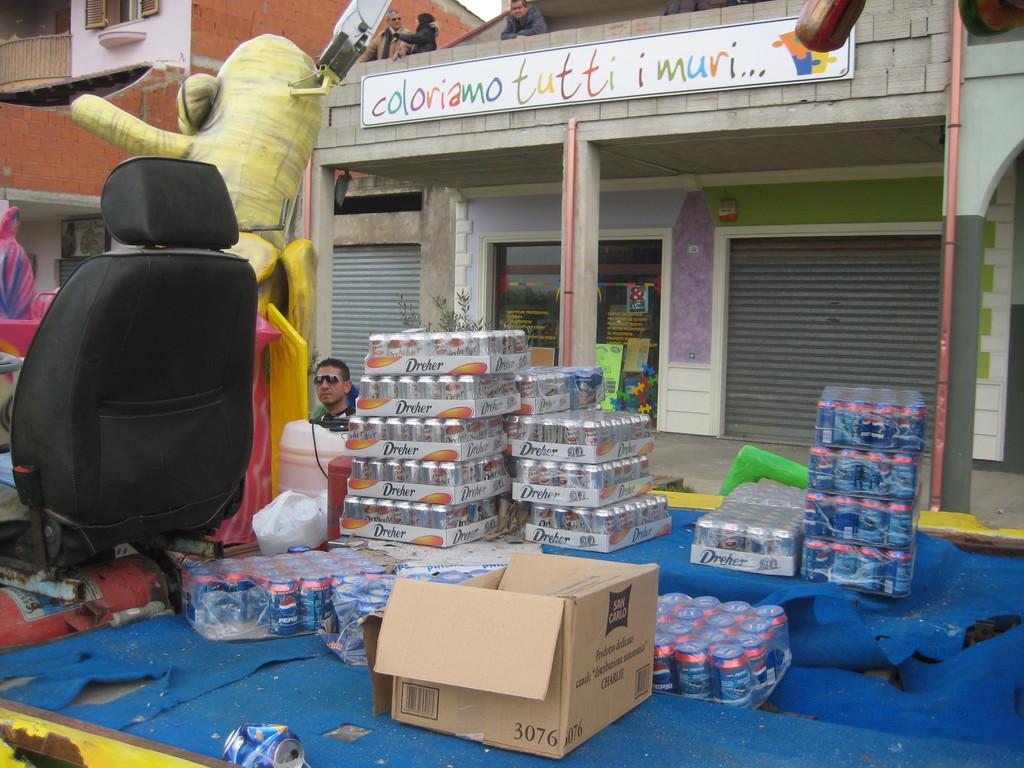What brand of soda is shown here?
Your answer should be compact. Pepsi. What is written on the banner?
Offer a terse response. Coloriamo tutti i muri. 